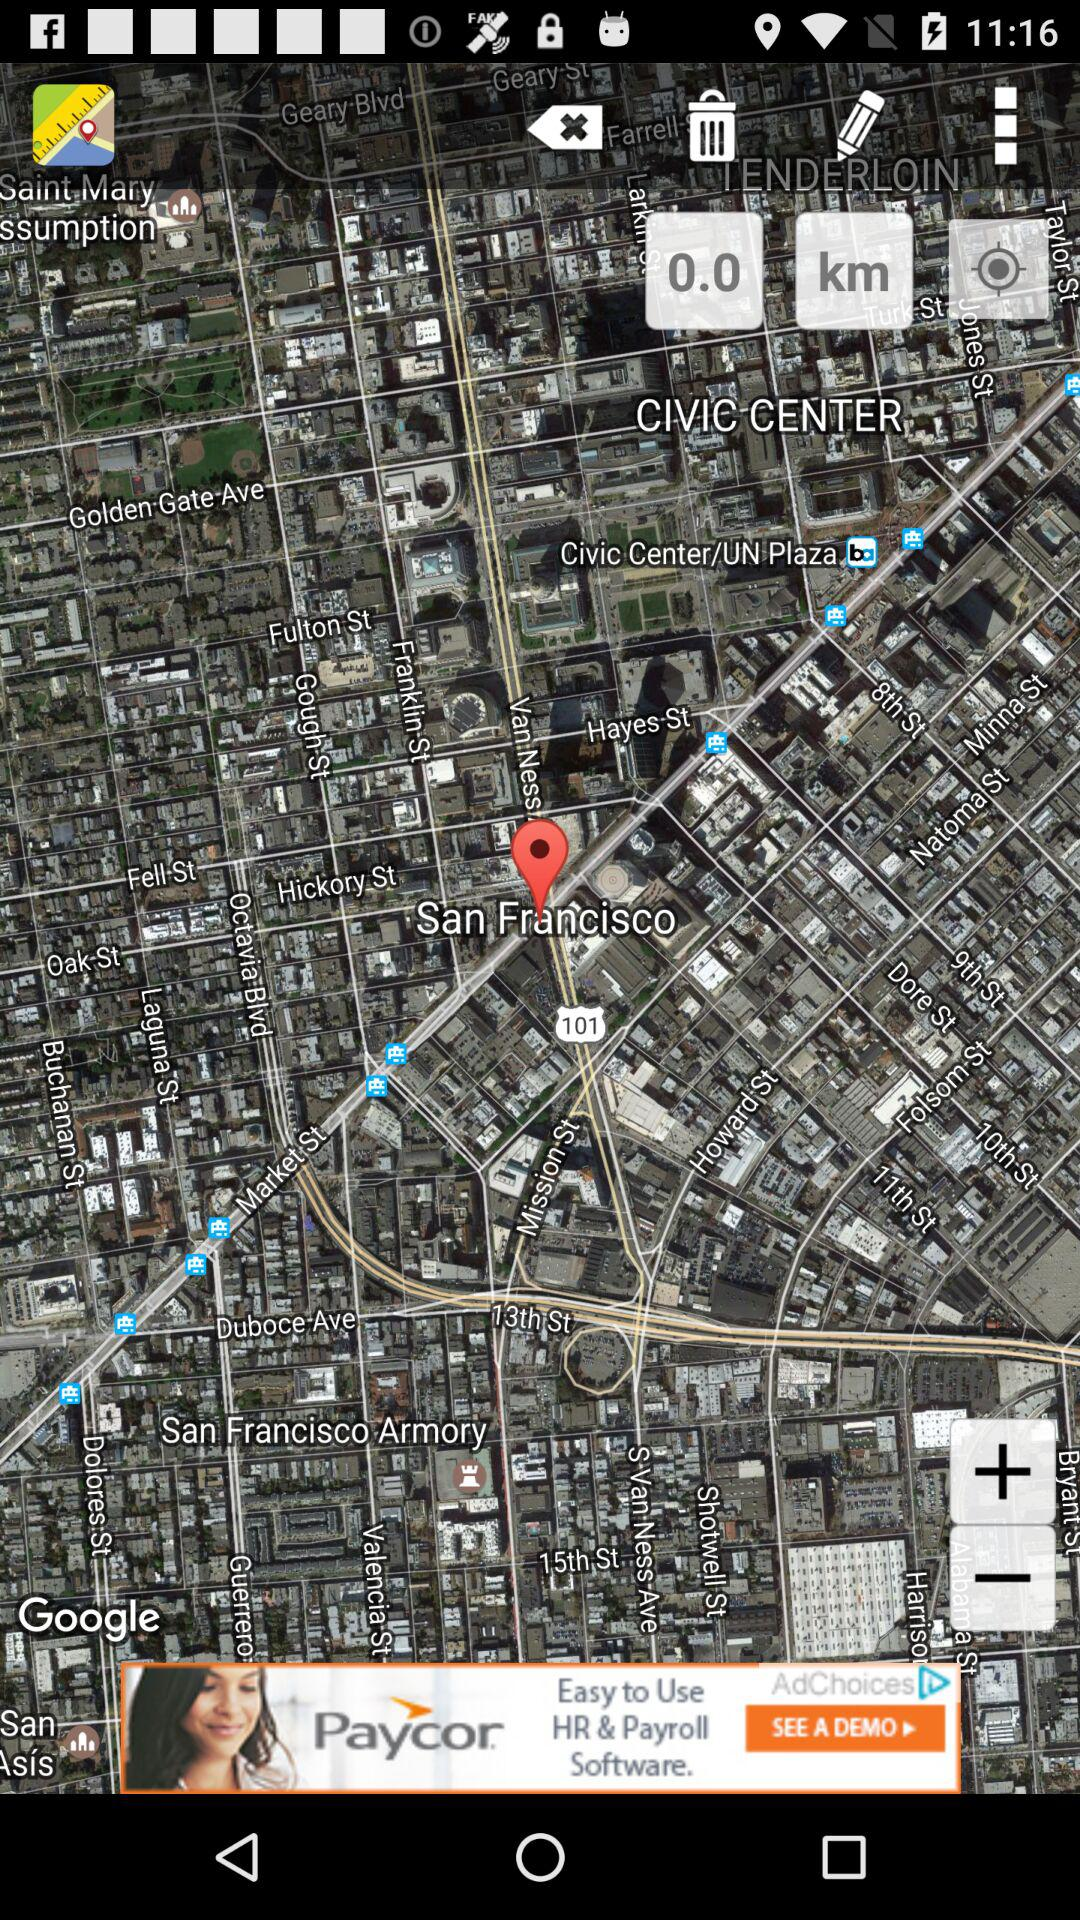What distance is shown on the screen in kilometers? The distance shown on the screen in kilometers is 0.0. 